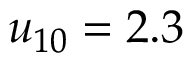<formula> <loc_0><loc_0><loc_500><loc_500>u _ { 1 0 } = 2 . 3</formula> 